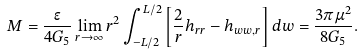Convert formula to latex. <formula><loc_0><loc_0><loc_500><loc_500>M = \frac { \epsilon } { 4 G _ { 5 } } \lim _ { r \rightarrow \infty } r ^ { 2 } \int _ { - L / 2 } ^ { L / 2 } \left [ \frac { 2 } { r } h _ { r r } - h _ { w w , r } \right ] d w = \frac { 3 \pi \mu ^ { 2 } } { 8 G _ { 5 } } .</formula> 